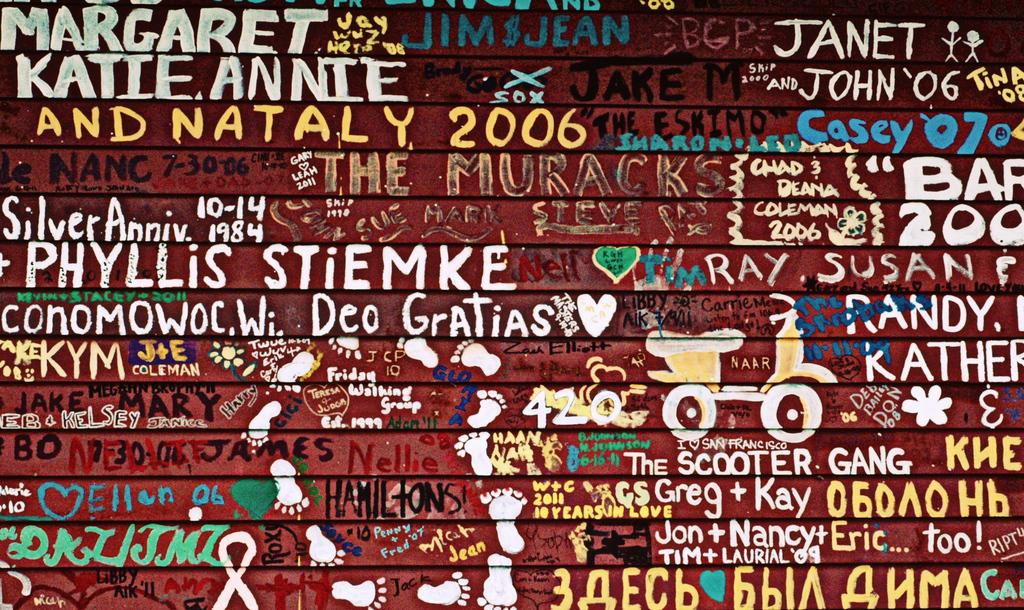What is present on the wall in the image? There is a wall in the image, and it has icons, text, and a painting on it. Can you describe the icons on the wall? Unfortunately, the specific icons on the wall cannot be described without more information. What type of text is present on the wall? The text on the wall cannot be described without more information. What is the subject of the painting on the wall? The subject of the painting on the wall cannot be described without more information. What color is the thumb in the image? There is no thumb present in the image. What type of joke is depicted in the painting on the wall? There is no joke depicted in the painting on the wall, as the subject of the painting cannot be described without more information. 